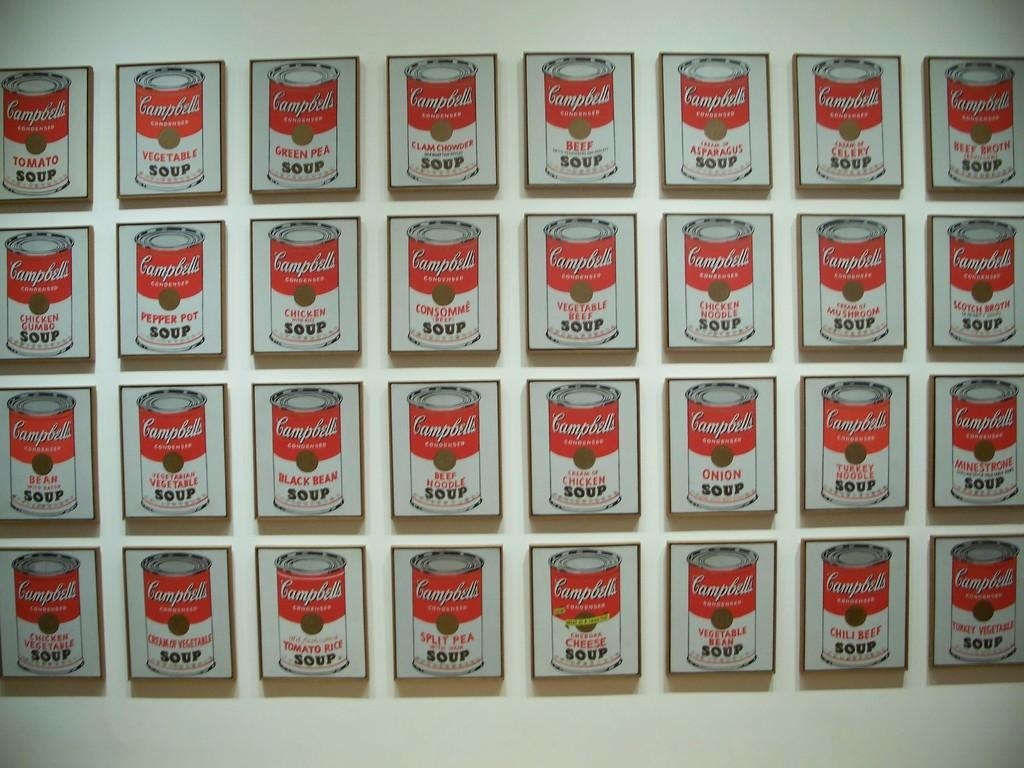<image>
Present a compact description of the photo's key features. Small wall hangings displaying different flavors of Campbell's Soup. 